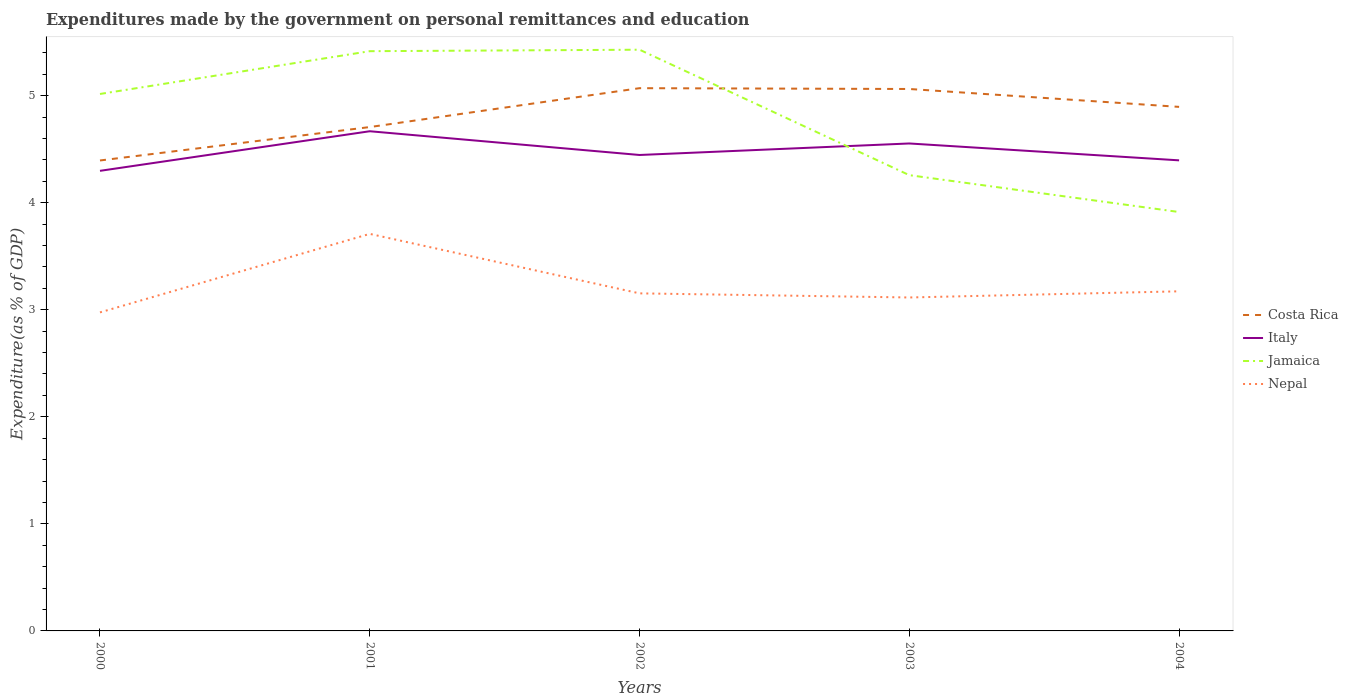Across all years, what is the maximum expenditures made by the government on personal remittances and education in Nepal?
Ensure brevity in your answer.  2.98. What is the total expenditures made by the government on personal remittances and education in Nepal in the graph?
Your response must be concise. 0.04. What is the difference between the highest and the second highest expenditures made by the government on personal remittances and education in Nepal?
Make the answer very short. 0.73. What is the difference between the highest and the lowest expenditures made by the government on personal remittances and education in Jamaica?
Your answer should be compact. 3. Is the expenditures made by the government on personal remittances and education in Jamaica strictly greater than the expenditures made by the government on personal remittances and education in Italy over the years?
Offer a very short reply. No. Does the graph contain any zero values?
Ensure brevity in your answer.  No. Does the graph contain grids?
Your answer should be compact. No. How many legend labels are there?
Provide a short and direct response. 4. What is the title of the graph?
Offer a terse response. Expenditures made by the government on personal remittances and education. Does "Uzbekistan" appear as one of the legend labels in the graph?
Provide a succinct answer. No. What is the label or title of the Y-axis?
Provide a succinct answer. Expenditure(as % of GDP). What is the Expenditure(as % of GDP) in Costa Rica in 2000?
Provide a short and direct response. 4.39. What is the Expenditure(as % of GDP) of Italy in 2000?
Your answer should be compact. 4.3. What is the Expenditure(as % of GDP) of Jamaica in 2000?
Your answer should be very brief. 5.02. What is the Expenditure(as % of GDP) in Nepal in 2000?
Make the answer very short. 2.98. What is the Expenditure(as % of GDP) of Costa Rica in 2001?
Your response must be concise. 4.71. What is the Expenditure(as % of GDP) in Italy in 2001?
Make the answer very short. 4.67. What is the Expenditure(as % of GDP) in Jamaica in 2001?
Your response must be concise. 5.41. What is the Expenditure(as % of GDP) in Nepal in 2001?
Ensure brevity in your answer.  3.71. What is the Expenditure(as % of GDP) in Costa Rica in 2002?
Offer a terse response. 5.07. What is the Expenditure(as % of GDP) in Italy in 2002?
Your answer should be compact. 4.45. What is the Expenditure(as % of GDP) of Jamaica in 2002?
Your answer should be compact. 5.43. What is the Expenditure(as % of GDP) in Nepal in 2002?
Provide a succinct answer. 3.15. What is the Expenditure(as % of GDP) in Costa Rica in 2003?
Your answer should be very brief. 5.06. What is the Expenditure(as % of GDP) in Italy in 2003?
Offer a terse response. 4.55. What is the Expenditure(as % of GDP) of Jamaica in 2003?
Ensure brevity in your answer.  4.26. What is the Expenditure(as % of GDP) of Nepal in 2003?
Your answer should be compact. 3.11. What is the Expenditure(as % of GDP) in Costa Rica in 2004?
Ensure brevity in your answer.  4.89. What is the Expenditure(as % of GDP) of Italy in 2004?
Your answer should be compact. 4.4. What is the Expenditure(as % of GDP) in Jamaica in 2004?
Provide a succinct answer. 3.91. What is the Expenditure(as % of GDP) of Nepal in 2004?
Provide a succinct answer. 3.17. Across all years, what is the maximum Expenditure(as % of GDP) of Costa Rica?
Give a very brief answer. 5.07. Across all years, what is the maximum Expenditure(as % of GDP) in Italy?
Keep it short and to the point. 4.67. Across all years, what is the maximum Expenditure(as % of GDP) of Jamaica?
Your answer should be very brief. 5.43. Across all years, what is the maximum Expenditure(as % of GDP) in Nepal?
Ensure brevity in your answer.  3.71. Across all years, what is the minimum Expenditure(as % of GDP) of Costa Rica?
Offer a very short reply. 4.39. Across all years, what is the minimum Expenditure(as % of GDP) in Italy?
Offer a terse response. 4.3. Across all years, what is the minimum Expenditure(as % of GDP) in Jamaica?
Your answer should be compact. 3.91. Across all years, what is the minimum Expenditure(as % of GDP) of Nepal?
Keep it short and to the point. 2.98. What is the total Expenditure(as % of GDP) in Costa Rica in the graph?
Your answer should be very brief. 24.13. What is the total Expenditure(as % of GDP) in Italy in the graph?
Provide a short and direct response. 22.36. What is the total Expenditure(as % of GDP) in Jamaica in the graph?
Offer a very short reply. 24.03. What is the total Expenditure(as % of GDP) of Nepal in the graph?
Provide a succinct answer. 16.12. What is the difference between the Expenditure(as % of GDP) in Costa Rica in 2000 and that in 2001?
Provide a succinct answer. -0.31. What is the difference between the Expenditure(as % of GDP) in Italy in 2000 and that in 2001?
Keep it short and to the point. -0.37. What is the difference between the Expenditure(as % of GDP) of Jamaica in 2000 and that in 2001?
Give a very brief answer. -0.4. What is the difference between the Expenditure(as % of GDP) of Nepal in 2000 and that in 2001?
Ensure brevity in your answer.  -0.73. What is the difference between the Expenditure(as % of GDP) in Costa Rica in 2000 and that in 2002?
Your answer should be compact. -0.68. What is the difference between the Expenditure(as % of GDP) of Italy in 2000 and that in 2002?
Your answer should be compact. -0.15. What is the difference between the Expenditure(as % of GDP) in Jamaica in 2000 and that in 2002?
Provide a succinct answer. -0.41. What is the difference between the Expenditure(as % of GDP) of Nepal in 2000 and that in 2002?
Provide a short and direct response. -0.18. What is the difference between the Expenditure(as % of GDP) of Costa Rica in 2000 and that in 2003?
Offer a very short reply. -0.67. What is the difference between the Expenditure(as % of GDP) of Italy in 2000 and that in 2003?
Provide a succinct answer. -0.26. What is the difference between the Expenditure(as % of GDP) in Jamaica in 2000 and that in 2003?
Give a very brief answer. 0.76. What is the difference between the Expenditure(as % of GDP) in Nepal in 2000 and that in 2003?
Keep it short and to the point. -0.14. What is the difference between the Expenditure(as % of GDP) of Costa Rica in 2000 and that in 2004?
Give a very brief answer. -0.5. What is the difference between the Expenditure(as % of GDP) of Italy in 2000 and that in 2004?
Your answer should be compact. -0.1. What is the difference between the Expenditure(as % of GDP) of Jamaica in 2000 and that in 2004?
Keep it short and to the point. 1.1. What is the difference between the Expenditure(as % of GDP) of Nepal in 2000 and that in 2004?
Make the answer very short. -0.2. What is the difference between the Expenditure(as % of GDP) of Costa Rica in 2001 and that in 2002?
Make the answer very short. -0.36. What is the difference between the Expenditure(as % of GDP) in Italy in 2001 and that in 2002?
Offer a terse response. 0.22. What is the difference between the Expenditure(as % of GDP) of Jamaica in 2001 and that in 2002?
Your answer should be very brief. -0.01. What is the difference between the Expenditure(as % of GDP) of Nepal in 2001 and that in 2002?
Provide a succinct answer. 0.56. What is the difference between the Expenditure(as % of GDP) in Costa Rica in 2001 and that in 2003?
Offer a very short reply. -0.36. What is the difference between the Expenditure(as % of GDP) in Italy in 2001 and that in 2003?
Your answer should be very brief. 0.11. What is the difference between the Expenditure(as % of GDP) of Jamaica in 2001 and that in 2003?
Provide a succinct answer. 1.16. What is the difference between the Expenditure(as % of GDP) in Nepal in 2001 and that in 2003?
Provide a short and direct response. 0.59. What is the difference between the Expenditure(as % of GDP) of Costa Rica in 2001 and that in 2004?
Make the answer very short. -0.19. What is the difference between the Expenditure(as % of GDP) of Italy in 2001 and that in 2004?
Your answer should be compact. 0.27. What is the difference between the Expenditure(as % of GDP) in Jamaica in 2001 and that in 2004?
Provide a short and direct response. 1.5. What is the difference between the Expenditure(as % of GDP) in Nepal in 2001 and that in 2004?
Give a very brief answer. 0.54. What is the difference between the Expenditure(as % of GDP) of Costa Rica in 2002 and that in 2003?
Your answer should be very brief. 0.01. What is the difference between the Expenditure(as % of GDP) in Italy in 2002 and that in 2003?
Offer a terse response. -0.11. What is the difference between the Expenditure(as % of GDP) in Jamaica in 2002 and that in 2003?
Your response must be concise. 1.17. What is the difference between the Expenditure(as % of GDP) in Nepal in 2002 and that in 2003?
Your answer should be compact. 0.04. What is the difference between the Expenditure(as % of GDP) in Costa Rica in 2002 and that in 2004?
Offer a very short reply. 0.17. What is the difference between the Expenditure(as % of GDP) in Italy in 2002 and that in 2004?
Offer a very short reply. 0.05. What is the difference between the Expenditure(as % of GDP) in Jamaica in 2002 and that in 2004?
Offer a terse response. 1.52. What is the difference between the Expenditure(as % of GDP) of Nepal in 2002 and that in 2004?
Offer a terse response. -0.02. What is the difference between the Expenditure(as % of GDP) of Costa Rica in 2003 and that in 2004?
Offer a very short reply. 0.17. What is the difference between the Expenditure(as % of GDP) of Italy in 2003 and that in 2004?
Offer a very short reply. 0.16. What is the difference between the Expenditure(as % of GDP) of Jamaica in 2003 and that in 2004?
Provide a succinct answer. 0.34. What is the difference between the Expenditure(as % of GDP) of Nepal in 2003 and that in 2004?
Keep it short and to the point. -0.06. What is the difference between the Expenditure(as % of GDP) in Costa Rica in 2000 and the Expenditure(as % of GDP) in Italy in 2001?
Your answer should be very brief. -0.27. What is the difference between the Expenditure(as % of GDP) of Costa Rica in 2000 and the Expenditure(as % of GDP) of Jamaica in 2001?
Ensure brevity in your answer.  -1.02. What is the difference between the Expenditure(as % of GDP) in Costa Rica in 2000 and the Expenditure(as % of GDP) in Nepal in 2001?
Your response must be concise. 0.69. What is the difference between the Expenditure(as % of GDP) in Italy in 2000 and the Expenditure(as % of GDP) in Jamaica in 2001?
Make the answer very short. -1.12. What is the difference between the Expenditure(as % of GDP) of Italy in 2000 and the Expenditure(as % of GDP) of Nepal in 2001?
Your answer should be compact. 0.59. What is the difference between the Expenditure(as % of GDP) in Jamaica in 2000 and the Expenditure(as % of GDP) in Nepal in 2001?
Offer a terse response. 1.31. What is the difference between the Expenditure(as % of GDP) in Costa Rica in 2000 and the Expenditure(as % of GDP) in Italy in 2002?
Offer a very short reply. -0.05. What is the difference between the Expenditure(as % of GDP) of Costa Rica in 2000 and the Expenditure(as % of GDP) of Jamaica in 2002?
Provide a short and direct response. -1.03. What is the difference between the Expenditure(as % of GDP) in Costa Rica in 2000 and the Expenditure(as % of GDP) in Nepal in 2002?
Keep it short and to the point. 1.24. What is the difference between the Expenditure(as % of GDP) of Italy in 2000 and the Expenditure(as % of GDP) of Jamaica in 2002?
Your answer should be compact. -1.13. What is the difference between the Expenditure(as % of GDP) in Italy in 2000 and the Expenditure(as % of GDP) in Nepal in 2002?
Provide a succinct answer. 1.14. What is the difference between the Expenditure(as % of GDP) of Jamaica in 2000 and the Expenditure(as % of GDP) of Nepal in 2002?
Your response must be concise. 1.86. What is the difference between the Expenditure(as % of GDP) in Costa Rica in 2000 and the Expenditure(as % of GDP) in Italy in 2003?
Make the answer very short. -0.16. What is the difference between the Expenditure(as % of GDP) of Costa Rica in 2000 and the Expenditure(as % of GDP) of Jamaica in 2003?
Make the answer very short. 0.14. What is the difference between the Expenditure(as % of GDP) of Costa Rica in 2000 and the Expenditure(as % of GDP) of Nepal in 2003?
Provide a short and direct response. 1.28. What is the difference between the Expenditure(as % of GDP) in Italy in 2000 and the Expenditure(as % of GDP) in Jamaica in 2003?
Your response must be concise. 0.04. What is the difference between the Expenditure(as % of GDP) in Italy in 2000 and the Expenditure(as % of GDP) in Nepal in 2003?
Make the answer very short. 1.18. What is the difference between the Expenditure(as % of GDP) in Jamaica in 2000 and the Expenditure(as % of GDP) in Nepal in 2003?
Your response must be concise. 1.9. What is the difference between the Expenditure(as % of GDP) in Costa Rica in 2000 and the Expenditure(as % of GDP) in Italy in 2004?
Offer a very short reply. -0. What is the difference between the Expenditure(as % of GDP) in Costa Rica in 2000 and the Expenditure(as % of GDP) in Jamaica in 2004?
Keep it short and to the point. 0.48. What is the difference between the Expenditure(as % of GDP) of Costa Rica in 2000 and the Expenditure(as % of GDP) of Nepal in 2004?
Keep it short and to the point. 1.22. What is the difference between the Expenditure(as % of GDP) of Italy in 2000 and the Expenditure(as % of GDP) of Jamaica in 2004?
Give a very brief answer. 0.38. What is the difference between the Expenditure(as % of GDP) in Italy in 2000 and the Expenditure(as % of GDP) in Nepal in 2004?
Your answer should be very brief. 1.13. What is the difference between the Expenditure(as % of GDP) in Jamaica in 2000 and the Expenditure(as % of GDP) in Nepal in 2004?
Ensure brevity in your answer.  1.84. What is the difference between the Expenditure(as % of GDP) of Costa Rica in 2001 and the Expenditure(as % of GDP) of Italy in 2002?
Ensure brevity in your answer.  0.26. What is the difference between the Expenditure(as % of GDP) of Costa Rica in 2001 and the Expenditure(as % of GDP) of Jamaica in 2002?
Give a very brief answer. -0.72. What is the difference between the Expenditure(as % of GDP) of Costa Rica in 2001 and the Expenditure(as % of GDP) of Nepal in 2002?
Provide a short and direct response. 1.55. What is the difference between the Expenditure(as % of GDP) of Italy in 2001 and the Expenditure(as % of GDP) of Jamaica in 2002?
Your response must be concise. -0.76. What is the difference between the Expenditure(as % of GDP) in Italy in 2001 and the Expenditure(as % of GDP) in Nepal in 2002?
Give a very brief answer. 1.51. What is the difference between the Expenditure(as % of GDP) in Jamaica in 2001 and the Expenditure(as % of GDP) in Nepal in 2002?
Ensure brevity in your answer.  2.26. What is the difference between the Expenditure(as % of GDP) in Costa Rica in 2001 and the Expenditure(as % of GDP) in Italy in 2003?
Provide a short and direct response. 0.15. What is the difference between the Expenditure(as % of GDP) in Costa Rica in 2001 and the Expenditure(as % of GDP) in Jamaica in 2003?
Give a very brief answer. 0.45. What is the difference between the Expenditure(as % of GDP) of Costa Rica in 2001 and the Expenditure(as % of GDP) of Nepal in 2003?
Provide a succinct answer. 1.59. What is the difference between the Expenditure(as % of GDP) in Italy in 2001 and the Expenditure(as % of GDP) in Jamaica in 2003?
Offer a very short reply. 0.41. What is the difference between the Expenditure(as % of GDP) in Italy in 2001 and the Expenditure(as % of GDP) in Nepal in 2003?
Offer a terse response. 1.55. What is the difference between the Expenditure(as % of GDP) in Jamaica in 2001 and the Expenditure(as % of GDP) in Nepal in 2003?
Your answer should be compact. 2.3. What is the difference between the Expenditure(as % of GDP) in Costa Rica in 2001 and the Expenditure(as % of GDP) in Italy in 2004?
Give a very brief answer. 0.31. What is the difference between the Expenditure(as % of GDP) of Costa Rica in 2001 and the Expenditure(as % of GDP) of Jamaica in 2004?
Offer a terse response. 0.79. What is the difference between the Expenditure(as % of GDP) in Costa Rica in 2001 and the Expenditure(as % of GDP) in Nepal in 2004?
Offer a very short reply. 1.53. What is the difference between the Expenditure(as % of GDP) of Italy in 2001 and the Expenditure(as % of GDP) of Jamaica in 2004?
Provide a succinct answer. 0.75. What is the difference between the Expenditure(as % of GDP) in Italy in 2001 and the Expenditure(as % of GDP) in Nepal in 2004?
Give a very brief answer. 1.5. What is the difference between the Expenditure(as % of GDP) in Jamaica in 2001 and the Expenditure(as % of GDP) in Nepal in 2004?
Your response must be concise. 2.24. What is the difference between the Expenditure(as % of GDP) of Costa Rica in 2002 and the Expenditure(as % of GDP) of Italy in 2003?
Give a very brief answer. 0.52. What is the difference between the Expenditure(as % of GDP) in Costa Rica in 2002 and the Expenditure(as % of GDP) in Jamaica in 2003?
Your answer should be very brief. 0.81. What is the difference between the Expenditure(as % of GDP) of Costa Rica in 2002 and the Expenditure(as % of GDP) of Nepal in 2003?
Provide a succinct answer. 1.95. What is the difference between the Expenditure(as % of GDP) in Italy in 2002 and the Expenditure(as % of GDP) in Jamaica in 2003?
Your answer should be compact. 0.19. What is the difference between the Expenditure(as % of GDP) in Italy in 2002 and the Expenditure(as % of GDP) in Nepal in 2003?
Keep it short and to the point. 1.33. What is the difference between the Expenditure(as % of GDP) in Jamaica in 2002 and the Expenditure(as % of GDP) in Nepal in 2003?
Provide a succinct answer. 2.31. What is the difference between the Expenditure(as % of GDP) of Costa Rica in 2002 and the Expenditure(as % of GDP) of Italy in 2004?
Keep it short and to the point. 0.67. What is the difference between the Expenditure(as % of GDP) of Costa Rica in 2002 and the Expenditure(as % of GDP) of Jamaica in 2004?
Ensure brevity in your answer.  1.16. What is the difference between the Expenditure(as % of GDP) in Costa Rica in 2002 and the Expenditure(as % of GDP) in Nepal in 2004?
Give a very brief answer. 1.9. What is the difference between the Expenditure(as % of GDP) in Italy in 2002 and the Expenditure(as % of GDP) in Jamaica in 2004?
Give a very brief answer. 0.53. What is the difference between the Expenditure(as % of GDP) of Italy in 2002 and the Expenditure(as % of GDP) of Nepal in 2004?
Offer a very short reply. 1.27. What is the difference between the Expenditure(as % of GDP) in Jamaica in 2002 and the Expenditure(as % of GDP) in Nepal in 2004?
Ensure brevity in your answer.  2.26. What is the difference between the Expenditure(as % of GDP) in Costa Rica in 2003 and the Expenditure(as % of GDP) in Italy in 2004?
Offer a terse response. 0.67. What is the difference between the Expenditure(as % of GDP) in Costa Rica in 2003 and the Expenditure(as % of GDP) in Jamaica in 2004?
Ensure brevity in your answer.  1.15. What is the difference between the Expenditure(as % of GDP) of Costa Rica in 2003 and the Expenditure(as % of GDP) of Nepal in 2004?
Your answer should be compact. 1.89. What is the difference between the Expenditure(as % of GDP) in Italy in 2003 and the Expenditure(as % of GDP) in Jamaica in 2004?
Keep it short and to the point. 0.64. What is the difference between the Expenditure(as % of GDP) in Italy in 2003 and the Expenditure(as % of GDP) in Nepal in 2004?
Your response must be concise. 1.38. What is the difference between the Expenditure(as % of GDP) of Jamaica in 2003 and the Expenditure(as % of GDP) of Nepal in 2004?
Make the answer very short. 1.08. What is the average Expenditure(as % of GDP) of Costa Rica per year?
Provide a succinct answer. 4.83. What is the average Expenditure(as % of GDP) of Italy per year?
Provide a short and direct response. 4.47. What is the average Expenditure(as % of GDP) of Jamaica per year?
Your response must be concise. 4.81. What is the average Expenditure(as % of GDP) of Nepal per year?
Your response must be concise. 3.22. In the year 2000, what is the difference between the Expenditure(as % of GDP) of Costa Rica and Expenditure(as % of GDP) of Italy?
Ensure brevity in your answer.  0.1. In the year 2000, what is the difference between the Expenditure(as % of GDP) in Costa Rica and Expenditure(as % of GDP) in Jamaica?
Your answer should be very brief. -0.62. In the year 2000, what is the difference between the Expenditure(as % of GDP) in Costa Rica and Expenditure(as % of GDP) in Nepal?
Keep it short and to the point. 1.42. In the year 2000, what is the difference between the Expenditure(as % of GDP) in Italy and Expenditure(as % of GDP) in Jamaica?
Your answer should be very brief. -0.72. In the year 2000, what is the difference between the Expenditure(as % of GDP) of Italy and Expenditure(as % of GDP) of Nepal?
Offer a very short reply. 1.32. In the year 2000, what is the difference between the Expenditure(as % of GDP) in Jamaica and Expenditure(as % of GDP) in Nepal?
Provide a short and direct response. 2.04. In the year 2001, what is the difference between the Expenditure(as % of GDP) in Costa Rica and Expenditure(as % of GDP) in Italy?
Make the answer very short. 0.04. In the year 2001, what is the difference between the Expenditure(as % of GDP) of Costa Rica and Expenditure(as % of GDP) of Jamaica?
Your answer should be compact. -0.71. In the year 2001, what is the difference between the Expenditure(as % of GDP) of Costa Rica and Expenditure(as % of GDP) of Nepal?
Keep it short and to the point. 1. In the year 2001, what is the difference between the Expenditure(as % of GDP) of Italy and Expenditure(as % of GDP) of Jamaica?
Your answer should be compact. -0.75. In the year 2001, what is the difference between the Expenditure(as % of GDP) in Italy and Expenditure(as % of GDP) in Nepal?
Your answer should be compact. 0.96. In the year 2001, what is the difference between the Expenditure(as % of GDP) of Jamaica and Expenditure(as % of GDP) of Nepal?
Give a very brief answer. 1.71. In the year 2002, what is the difference between the Expenditure(as % of GDP) in Costa Rica and Expenditure(as % of GDP) in Italy?
Keep it short and to the point. 0.62. In the year 2002, what is the difference between the Expenditure(as % of GDP) in Costa Rica and Expenditure(as % of GDP) in Jamaica?
Ensure brevity in your answer.  -0.36. In the year 2002, what is the difference between the Expenditure(as % of GDP) in Costa Rica and Expenditure(as % of GDP) in Nepal?
Your response must be concise. 1.92. In the year 2002, what is the difference between the Expenditure(as % of GDP) of Italy and Expenditure(as % of GDP) of Jamaica?
Provide a short and direct response. -0.98. In the year 2002, what is the difference between the Expenditure(as % of GDP) of Italy and Expenditure(as % of GDP) of Nepal?
Provide a succinct answer. 1.29. In the year 2002, what is the difference between the Expenditure(as % of GDP) of Jamaica and Expenditure(as % of GDP) of Nepal?
Your response must be concise. 2.28. In the year 2003, what is the difference between the Expenditure(as % of GDP) of Costa Rica and Expenditure(as % of GDP) of Italy?
Offer a very short reply. 0.51. In the year 2003, what is the difference between the Expenditure(as % of GDP) of Costa Rica and Expenditure(as % of GDP) of Jamaica?
Make the answer very short. 0.8. In the year 2003, what is the difference between the Expenditure(as % of GDP) in Costa Rica and Expenditure(as % of GDP) in Nepal?
Offer a very short reply. 1.95. In the year 2003, what is the difference between the Expenditure(as % of GDP) of Italy and Expenditure(as % of GDP) of Jamaica?
Give a very brief answer. 0.3. In the year 2003, what is the difference between the Expenditure(as % of GDP) of Italy and Expenditure(as % of GDP) of Nepal?
Provide a succinct answer. 1.44. In the year 2003, what is the difference between the Expenditure(as % of GDP) of Jamaica and Expenditure(as % of GDP) of Nepal?
Ensure brevity in your answer.  1.14. In the year 2004, what is the difference between the Expenditure(as % of GDP) of Costa Rica and Expenditure(as % of GDP) of Italy?
Make the answer very short. 0.5. In the year 2004, what is the difference between the Expenditure(as % of GDP) of Costa Rica and Expenditure(as % of GDP) of Nepal?
Your answer should be very brief. 1.72. In the year 2004, what is the difference between the Expenditure(as % of GDP) in Italy and Expenditure(as % of GDP) in Jamaica?
Your answer should be compact. 0.48. In the year 2004, what is the difference between the Expenditure(as % of GDP) in Italy and Expenditure(as % of GDP) in Nepal?
Your answer should be compact. 1.22. In the year 2004, what is the difference between the Expenditure(as % of GDP) of Jamaica and Expenditure(as % of GDP) of Nepal?
Offer a very short reply. 0.74. What is the ratio of the Expenditure(as % of GDP) of Costa Rica in 2000 to that in 2001?
Provide a succinct answer. 0.93. What is the ratio of the Expenditure(as % of GDP) of Italy in 2000 to that in 2001?
Your answer should be very brief. 0.92. What is the ratio of the Expenditure(as % of GDP) of Jamaica in 2000 to that in 2001?
Give a very brief answer. 0.93. What is the ratio of the Expenditure(as % of GDP) in Nepal in 2000 to that in 2001?
Your answer should be compact. 0.8. What is the ratio of the Expenditure(as % of GDP) of Costa Rica in 2000 to that in 2002?
Your answer should be compact. 0.87. What is the ratio of the Expenditure(as % of GDP) in Italy in 2000 to that in 2002?
Your answer should be very brief. 0.97. What is the ratio of the Expenditure(as % of GDP) in Jamaica in 2000 to that in 2002?
Offer a terse response. 0.92. What is the ratio of the Expenditure(as % of GDP) of Nepal in 2000 to that in 2002?
Keep it short and to the point. 0.94. What is the ratio of the Expenditure(as % of GDP) of Costa Rica in 2000 to that in 2003?
Your response must be concise. 0.87. What is the ratio of the Expenditure(as % of GDP) in Italy in 2000 to that in 2003?
Provide a short and direct response. 0.94. What is the ratio of the Expenditure(as % of GDP) in Jamaica in 2000 to that in 2003?
Offer a terse response. 1.18. What is the ratio of the Expenditure(as % of GDP) of Nepal in 2000 to that in 2003?
Keep it short and to the point. 0.96. What is the ratio of the Expenditure(as % of GDP) in Costa Rica in 2000 to that in 2004?
Your response must be concise. 0.9. What is the ratio of the Expenditure(as % of GDP) of Italy in 2000 to that in 2004?
Your answer should be very brief. 0.98. What is the ratio of the Expenditure(as % of GDP) in Jamaica in 2000 to that in 2004?
Offer a very short reply. 1.28. What is the ratio of the Expenditure(as % of GDP) of Nepal in 2000 to that in 2004?
Provide a succinct answer. 0.94. What is the ratio of the Expenditure(as % of GDP) of Costa Rica in 2001 to that in 2002?
Keep it short and to the point. 0.93. What is the ratio of the Expenditure(as % of GDP) of Italy in 2001 to that in 2002?
Provide a short and direct response. 1.05. What is the ratio of the Expenditure(as % of GDP) of Nepal in 2001 to that in 2002?
Ensure brevity in your answer.  1.18. What is the ratio of the Expenditure(as % of GDP) in Costa Rica in 2001 to that in 2003?
Offer a terse response. 0.93. What is the ratio of the Expenditure(as % of GDP) in Italy in 2001 to that in 2003?
Offer a terse response. 1.03. What is the ratio of the Expenditure(as % of GDP) of Jamaica in 2001 to that in 2003?
Offer a terse response. 1.27. What is the ratio of the Expenditure(as % of GDP) of Nepal in 2001 to that in 2003?
Offer a terse response. 1.19. What is the ratio of the Expenditure(as % of GDP) in Costa Rica in 2001 to that in 2004?
Ensure brevity in your answer.  0.96. What is the ratio of the Expenditure(as % of GDP) in Italy in 2001 to that in 2004?
Make the answer very short. 1.06. What is the ratio of the Expenditure(as % of GDP) in Jamaica in 2001 to that in 2004?
Keep it short and to the point. 1.38. What is the ratio of the Expenditure(as % of GDP) in Nepal in 2001 to that in 2004?
Keep it short and to the point. 1.17. What is the ratio of the Expenditure(as % of GDP) of Italy in 2002 to that in 2003?
Offer a very short reply. 0.98. What is the ratio of the Expenditure(as % of GDP) in Jamaica in 2002 to that in 2003?
Provide a short and direct response. 1.28. What is the ratio of the Expenditure(as % of GDP) of Nepal in 2002 to that in 2003?
Offer a terse response. 1.01. What is the ratio of the Expenditure(as % of GDP) in Costa Rica in 2002 to that in 2004?
Make the answer very short. 1.04. What is the ratio of the Expenditure(as % of GDP) of Italy in 2002 to that in 2004?
Your response must be concise. 1.01. What is the ratio of the Expenditure(as % of GDP) in Jamaica in 2002 to that in 2004?
Ensure brevity in your answer.  1.39. What is the ratio of the Expenditure(as % of GDP) of Costa Rica in 2003 to that in 2004?
Your response must be concise. 1.03. What is the ratio of the Expenditure(as % of GDP) of Italy in 2003 to that in 2004?
Make the answer very short. 1.04. What is the ratio of the Expenditure(as % of GDP) of Jamaica in 2003 to that in 2004?
Keep it short and to the point. 1.09. What is the ratio of the Expenditure(as % of GDP) in Nepal in 2003 to that in 2004?
Make the answer very short. 0.98. What is the difference between the highest and the second highest Expenditure(as % of GDP) of Costa Rica?
Your answer should be very brief. 0.01. What is the difference between the highest and the second highest Expenditure(as % of GDP) of Italy?
Give a very brief answer. 0.11. What is the difference between the highest and the second highest Expenditure(as % of GDP) in Jamaica?
Your answer should be compact. 0.01. What is the difference between the highest and the second highest Expenditure(as % of GDP) of Nepal?
Keep it short and to the point. 0.54. What is the difference between the highest and the lowest Expenditure(as % of GDP) of Costa Rica?
Provide a short and direct response. 0.68. What is the difference between the highest and the lowest Expenditure(as % of GDP) in Italy?
Give a very brief answer. 0.37. What is the difference between the highest and the lowest Expenditure(as % of GDP) of Jamaica?
Provide a short and direct response. 1.52. What is the difference between the highest and the lowest Expenditure(as % of GDP) in Nepal?
Offer a terse response. 0.73. 